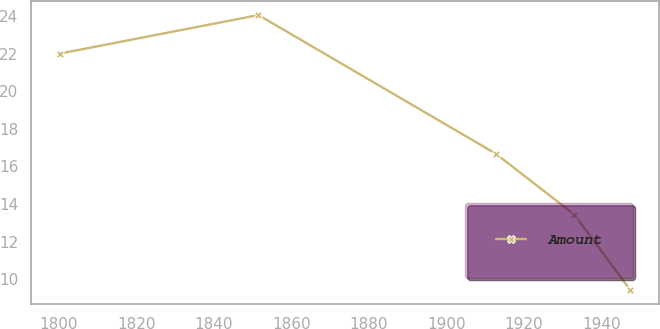Convert chart to OTSL. <chart><loc_0><loc_0><loc_500><loc_500><line_chart><ecel><fcel>Amount<nl><fcel>1800.35<fcel>22.01<nl><fcel>1851.53<fcel>24.06<nl><fcel>1912.72<fcel>16.68<nl><fcel>1932.97<fcel>13.44<nl><fcel>1947.41<fcel>9.42<nl></chart> 